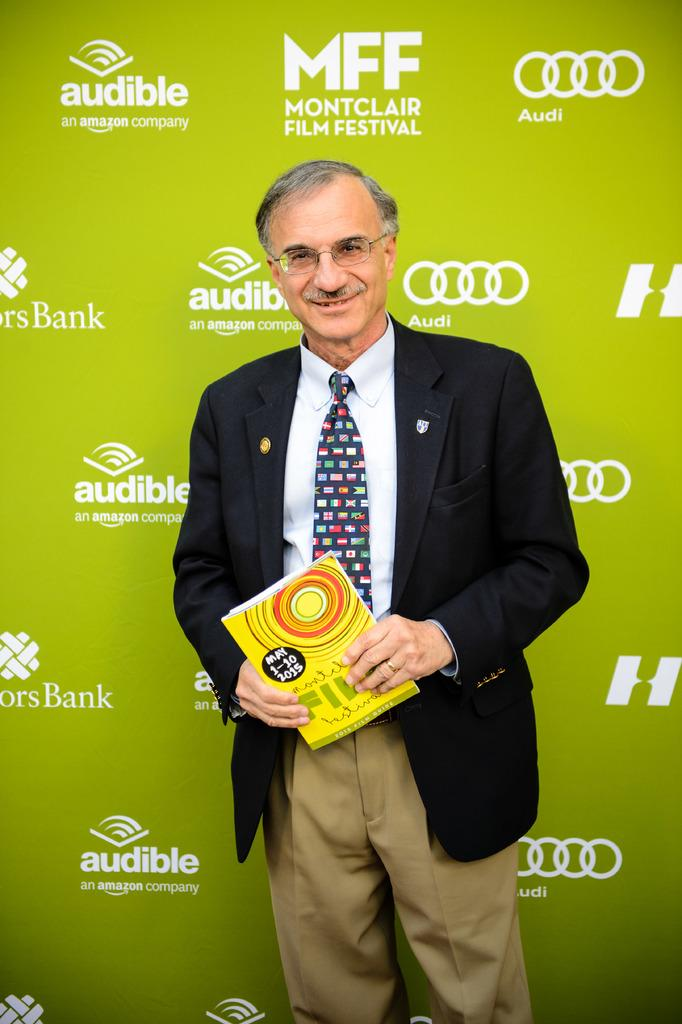What is the man in the image doing? The man is standing in the image. What is the man holding in the image? The man is holding an object. Can you describe the man's clothing in the image? The man is wearing a black coat and a tie. What can be seen in the background of the image? There is a poster in the background of the image. What is featured on the poster? The poster has logos on it. How many planes are flying in the image? There are no planes visible in the image. What type of credit card does the man have in the image? There is no credit card visible in the image. 